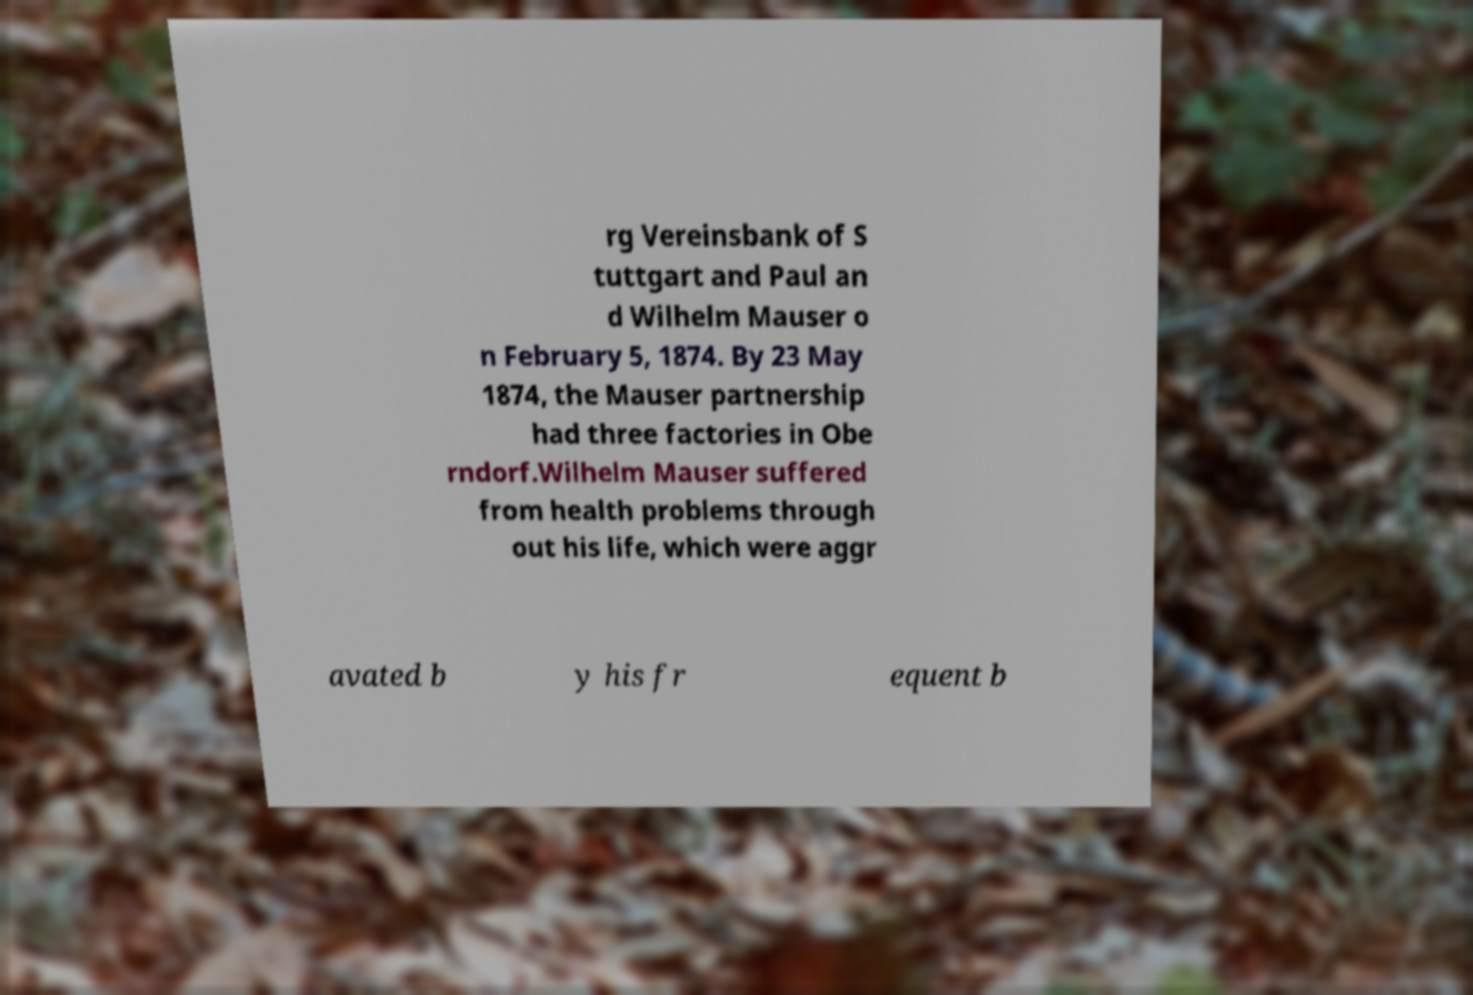Can you read and provide the text displayed in the image?This photo seems to have some interesting text. Can you extract and type it out for me? rg Vereinsbank of S tuttgart and Paul an d Wilhelm Mauser o n February 5, 1874. By 23 May 1874, the Mauser partnership had three factories in Obe rndorf.Wilhelm Mauser suffered from health problems through out his life, which were aggr avated b y his fr equent b 